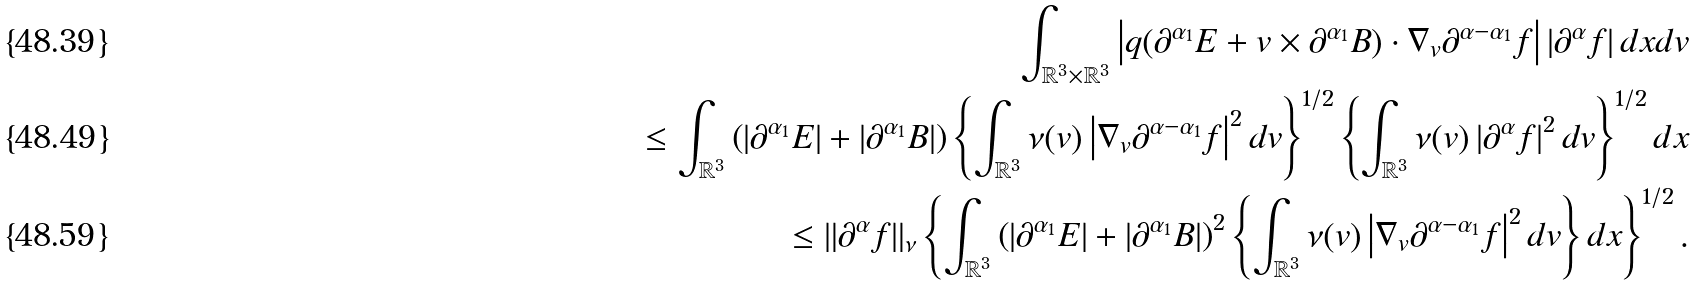Convert formula to latex. <formula><loc_0><loc_0><loc_500><loc_500>\int _ { \mathbb { R } ^ { 3 } \times \mathbb { R } ^ { 3 } } \left | q ( \partial ^ { \alpha _ { 1 } } E + v \times \partial ^ { \alpha _ { 1 } } B ) \cdot \nabla _ { v } \partial ^ { \alpha - \alpha _ { 1 } } f \right | \left | \partial ^ { \alpha } f \right | d x d v \\ \leq \int _ { \mathbb { R } ^ { 3 } } \left ( \left | \partial ^ { \alpha _ { 1 } } E \right | + \left | \partial ^ { \alpha _ { 1 } } B \right | \right ) \left \{ \int _ { \mathbb { R } ^ { 3 } } \nu ( v ) \left | \nabla _ { v } \partial ^ { \alpha - \alpha _ { 1 } } f \right | ^ { 2 } d v \right \} ^ { 1 / 2 } \left \{ \int _ { \mathbb { R } ^ { 3 } } \nu ( v ) \left | \partial ^ { \alpha } f \right | ^ { 2 } d v \right \} ^ { 1 / 2 } d x \\ \leq \| \partial ^ { \alpha } f \| _ { \nu } \left \{ \int _ { \mathbb { R } ^ { 3 } } \left ( \left | \partial ^ { \alpha _ { 1 } } E \right | + \left | \partial ^ { \alpha _ { 1 } } B \right | \right ) ^ { 2 } \left \{ \int _ { \mathbb { R } ^ { 3 } } \nu ( v ) \left | \nabla _ { v } \partial ^ { \alpha - \alpha _ { 1 } } f \right | ^ { 2 } d v \right \} d x \right \} ^ { 1 / 2 } .</formula> 